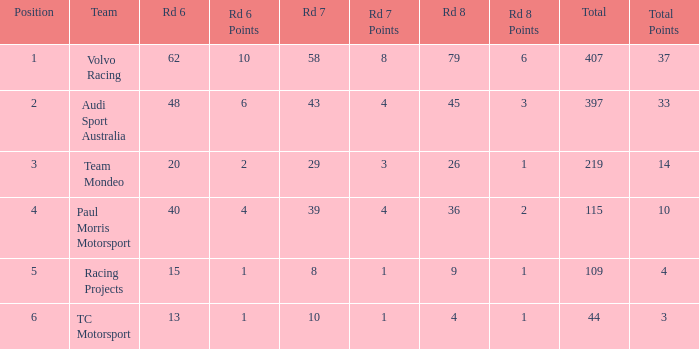What is the sum of values of Rd 7 with RD 6 less than 48 and Rd 8 less than 4 for TC Motorsport in a position greater than 1? None. 